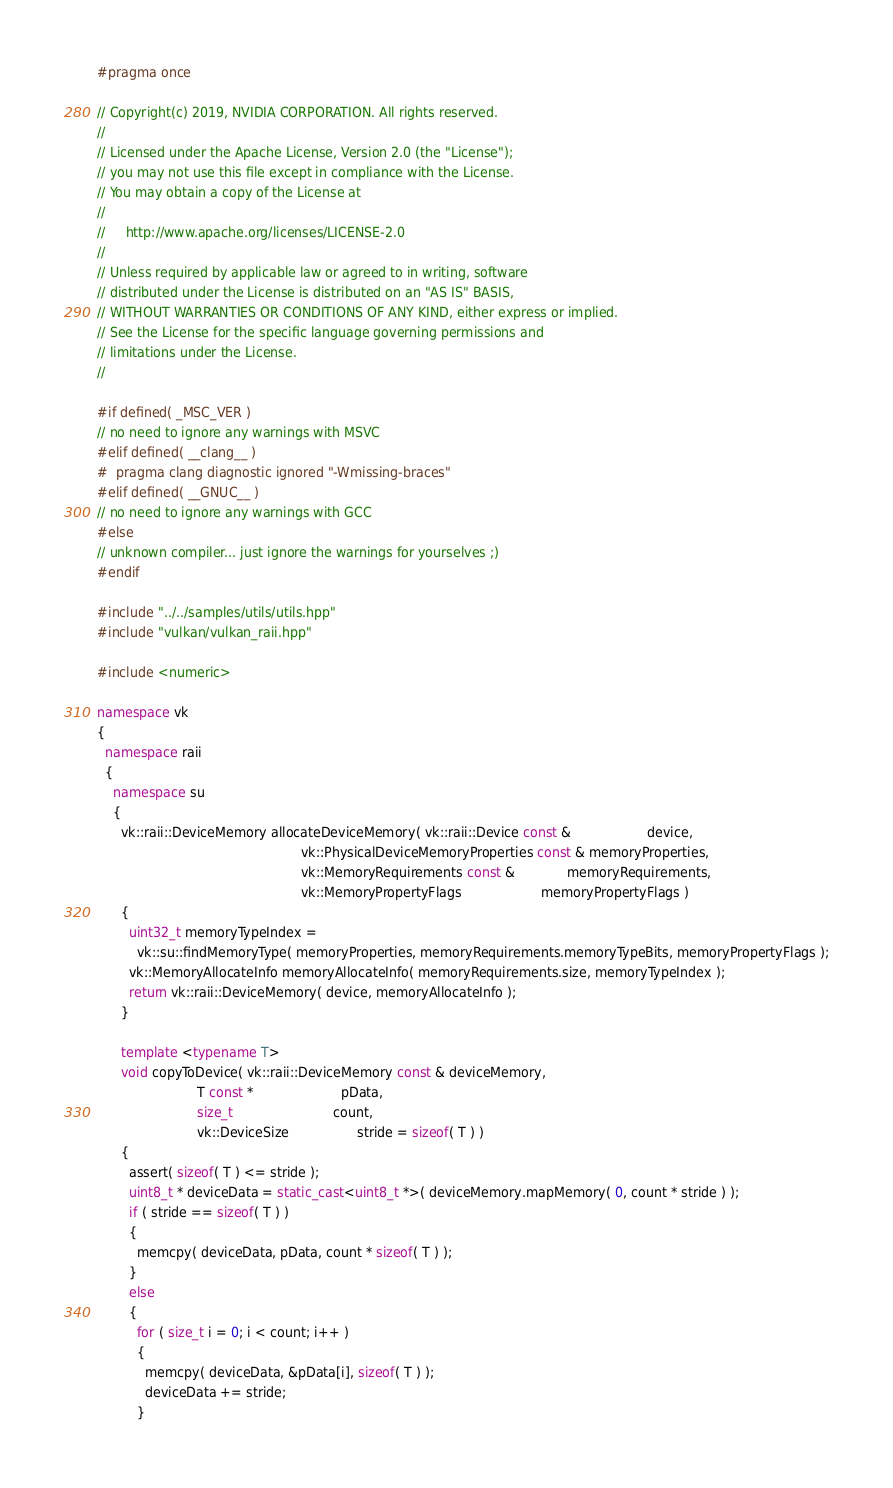<code> <loc_0><loc_0><loc_500><loc_500><_C++_>#pragma once

// Copyright(c) 2019, NVIDIA CORPORATION. All rights reserved.
//
// Licensed under the Apache License, Version 2.0 (the "License");
// you may not use this file except in compliance with the License.
// You may obtain a copy of the License at
//
//     http://www.apache.org/licenses/LICENSE-2.0
//
// Unless required by applicable law or agreed to in writing, software
// distributed under the License is distributed on an "AS IS" BASIS,
// WITHOUT WARRANTIES OR CONDITIONS OF ANY KIND, either express or implied.
// See the License for the specific language governing permissions and
// limitations under the License.
//

#if defined( _MSC_VER )
// no need to ignore any warnings with MSVC
#elif defined( __clang__ )
#  pragma clang diagnostic ignored "-Wmissing-braces"
#elif defined( __GNUC__ )
// no need to ignore any warnings with GCC
#else
// unknown compiler... just ignore the warnings for yourselves ;)
#endif

#include "../../samples/utils/utils.hpp"
#include "vulkan/vulkan_raii.hpp"

#include <numeric>

namespace vk
{
  namespace raii
  {
    namespace su
    {
      vk::raii::DeviceMemory allocateDeviceMemory( vk::raii::Device const &                   device,
                                                   vk::PhysicalDeviceMemoryProperties const & memoryProperties,
                                                   vk::MemoryRequirements const &             memoryRequirements,
                                                   vk::MemoryPropertyFlags                    memoryPropertyFlags )
      {
        uint32_t memoryTypeIndex =
          vk::su::findMemoryType( memoryProperties, memoryRequirements.memoryTypeBits, memoryPropertyFlags );
        vk::MemoryAllocateInfo memoryAllocateInfo( memoryRequirements.size, memoryTypeIndex );
        return vk::raii::DeviceMemory( device, memoryAllocateInfo );
      }

      template <typename T>
      void copyToDevice( vk::raii::DeviceMemory const & deviceMemory,
                         T const *                      pData,
                         size_t                         count,
                         vk::DeviceSize                 stride = sizeof( T ) )
      {
        assert( sizeof( T ) <= stride );
        uint8_t * deviceData = static_cast<uint8_t *>( deviceMemory.mapMemory( 0, count * stride ) );
        if ( stride == sizeof( T ) )
        {
          memcpy( deviceData, pData, count * sizeof( T ) );
        }
        else
        {
          for ( size_t i = 0; i < count; i++ )
          {
            memcpy( deviceData, &pData[i], sizeof( T ) );
            deviceData += stride;
          }</code> 